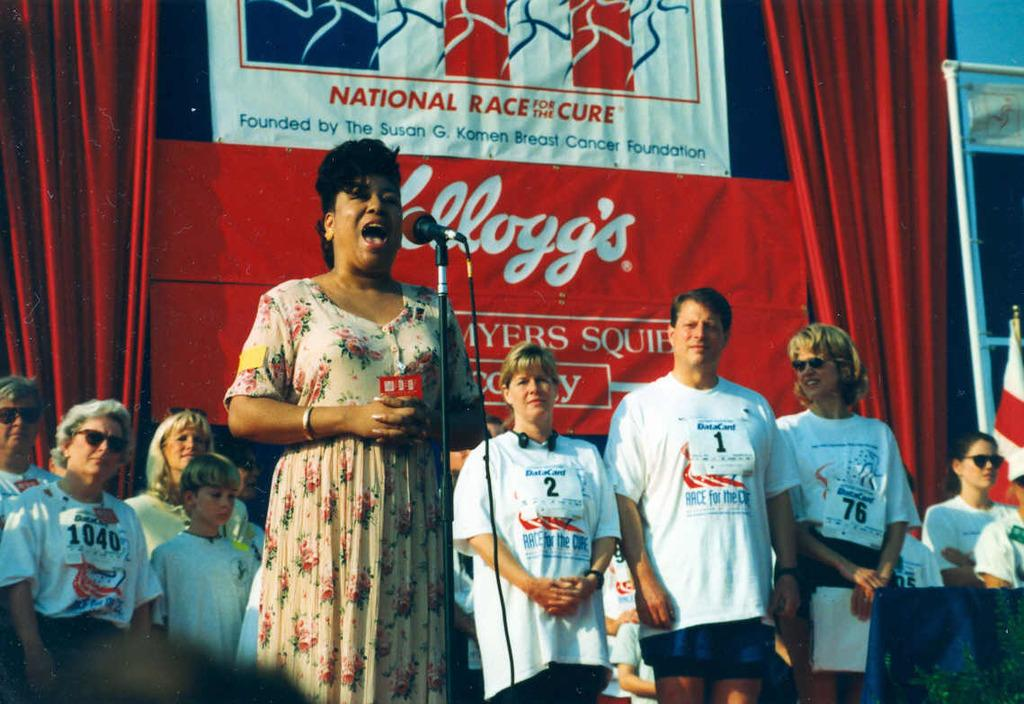What is the main subject of the image? There is a woman standing in the image. What object is present near the woman? There is a microphone with a stand in the image. Are there any other people in the image? Yes, there are other people standing in the image. What can be seen hanging or displayed in the image? There is a banner in the image. What type of apparatus can be seen on the woman's toes in the image? There is no apparatus present on the woman's toes in the image. What letter is written on the banner in the image? The provided facts do not mention any specific letters on the banner, so we cannot determine the letter from the image. 